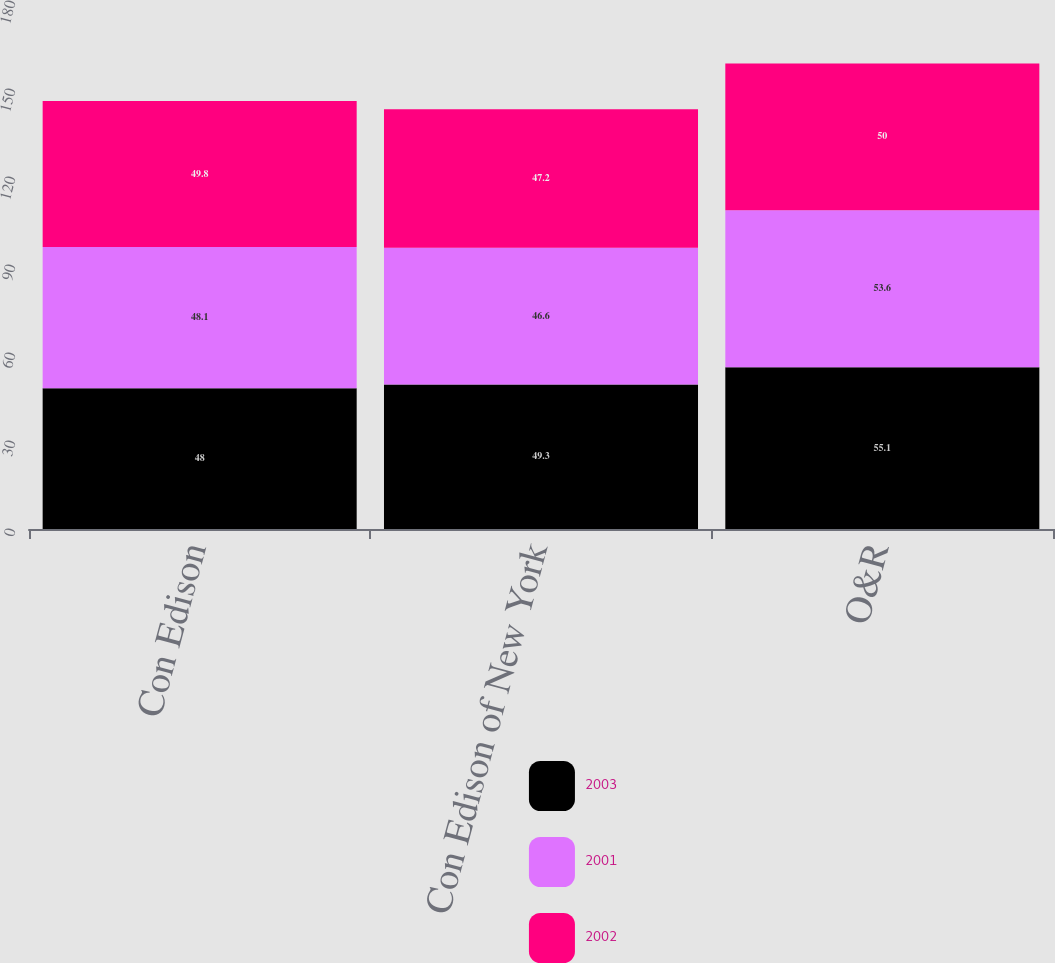<chart> <loc_0><loc_0><loc_500><loc_500><stacked_bar_chart><ecel><fcel>Con Edison<fcel>Con Edison of New York<fcel>O&R<nl><fcel>2003<fcel>48<fcel>49.3<fcel>55.1<nl><fcel>2001<fcel>48.1<fcel>46.6<fcel>53.6<nl><fcel>2002<fcel>49.8<fcel>47.2<fcel>50<nl></chart> 